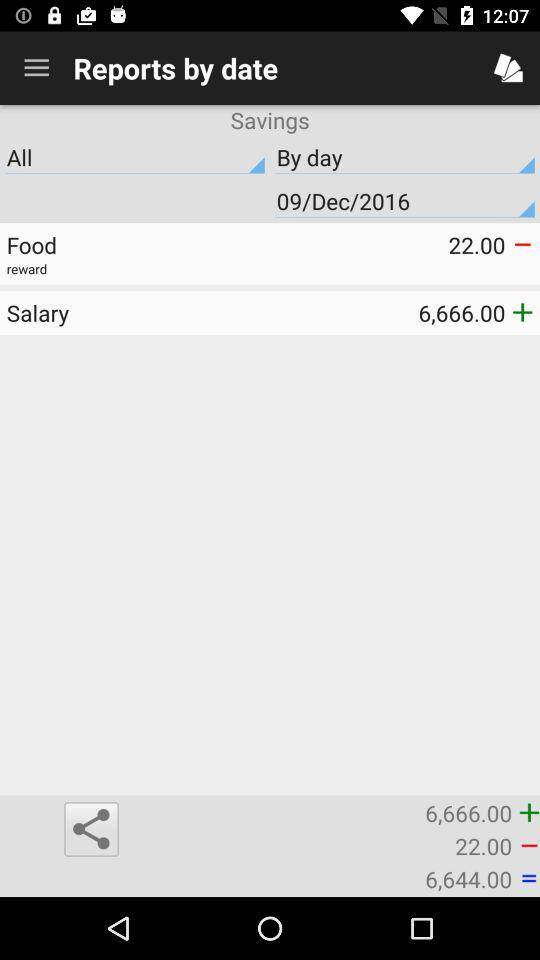What is the shown salary? The shown salary is 6,666. 